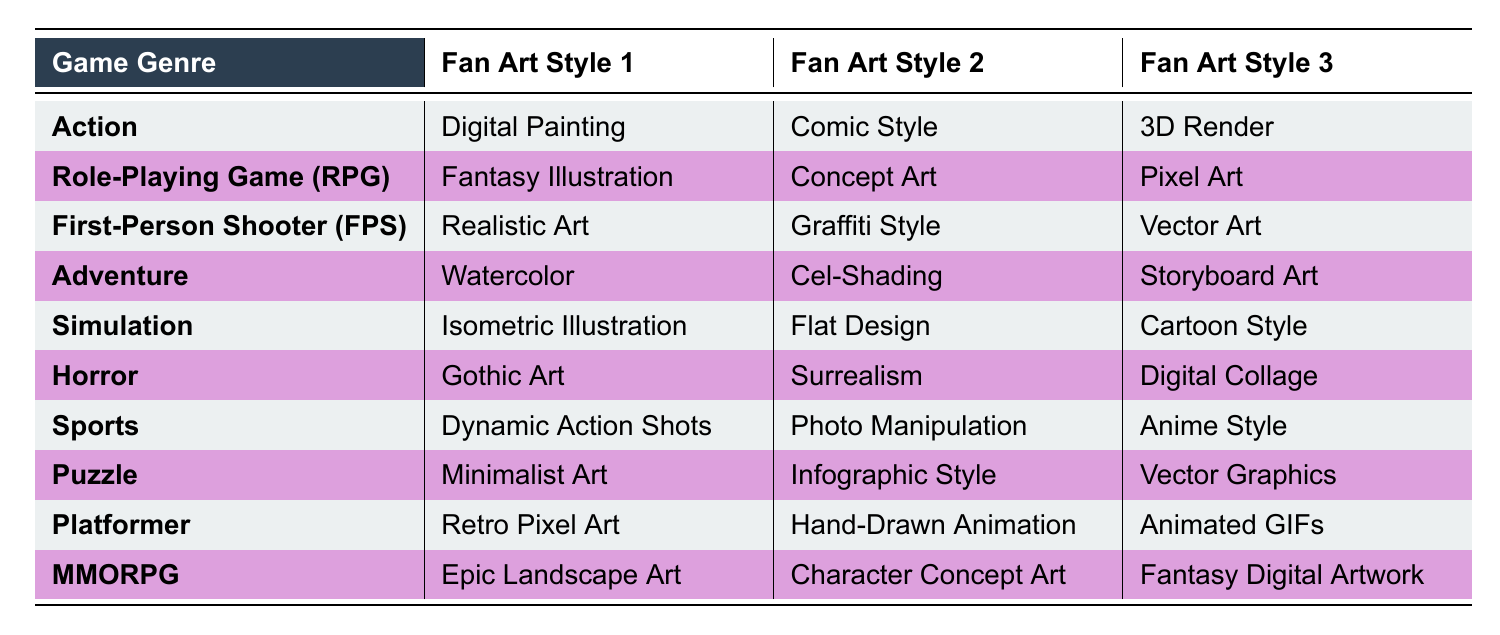What are the preferred fan art styles for the Horror genre? According to the table, the preferred fan art styles for the Horror genre are Gothic Art, Surrealism, and Digital Collage.
Answer: Gothic Art, Surrealism, Digital Collage Which fan art style is listed for both Action and Sports genres? The table shows that Digital Painting is a preferred style for Action, while Anime Style is listed for Sports. There is no shared fan art style between these two genres.
Answer: None True or False: Concept Art is a preferred fan art style for RPG. By examining the table, Concept Art is listed as one of the preferred fan art styles for the Role-Playing Game (RPG) genre, making the statement true.
Answer: True What is the total number of preferred fan art styles for all genres listed in the table? Each genre has three preferred fan art styles and there are 10 genres, so the total is 3 styles x 10 genres = 30 preferred fan art styles in total.
Answer: 30 Which genre has a preferred fan art style that is specifically noted as "Retro"? Looking at the table, Retro Pixel Art is identified as a preferred fan art style for the Platformer genre.
Answer: Platformer List the fan art styles for the First-Person Shooter genre. The table indicates that the preferred fan art styles for the First-Person Shooter (FPS) genre are Realistic Art, Graffiti Style, and Vector Art.
Answer: Realistic Art, Graffiti Style, Vector Art Identify any genre that includes "Art" in its preferred fan art styles and which one is it. Scanning through the table reveals that genres like Horror (Gothic Art, Surrealism, Digital Collage) and Role-Playing Game (RPG) (Fantasy Illustration) contain the word "Art" in their preferred styles. Horror is the genre that includes the most instances.
Answer: Horror Is there any genre that prefers Animated GIFs as a fan art style? The table states that the Platformer genre lists Animated GIFs as one of its preferred fan art styles, making the statement true.
Answer: True Which genres have preferred fan art styles that can be considered as illustrations? The Adventure genre (Watercolor, Cel-Shading, Storyboard Art) and Simulation genre (Isometric Illustration, Flat Design, Cartoon Style) both have styles that fall under the illustration category, indicating they share this trait.
Answer: Adventure, Simulation 